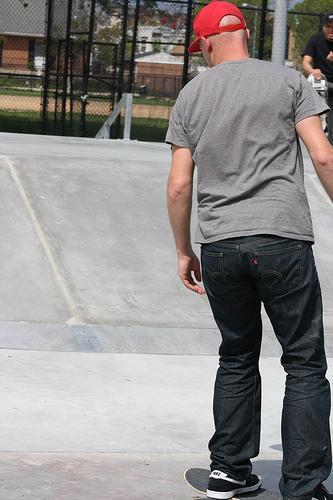How many people in the picture?
Give a very brief answer. 2. 